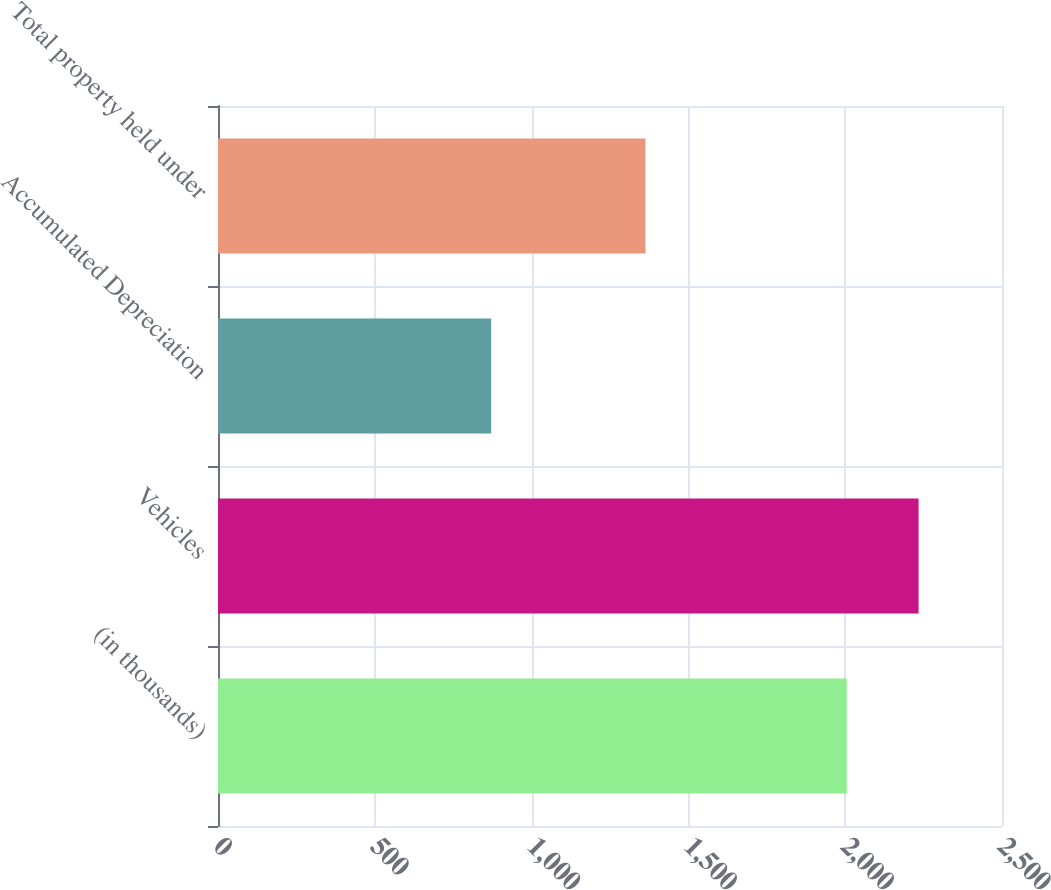<chart> <loc_0><loc_0><loc_500><loc_500><bar_chart><fcel>(in thousands)<fcel>Vehicles<fcel>Accumulated Depreciation<fcel>Total property held under<nl><fcel>2005<fcel>2234<fcel>871<fcel>1363<nl></chart> 